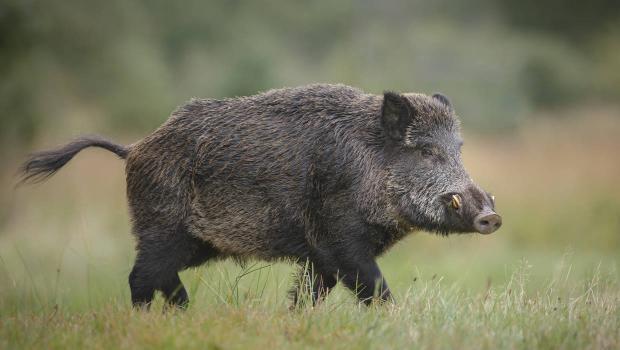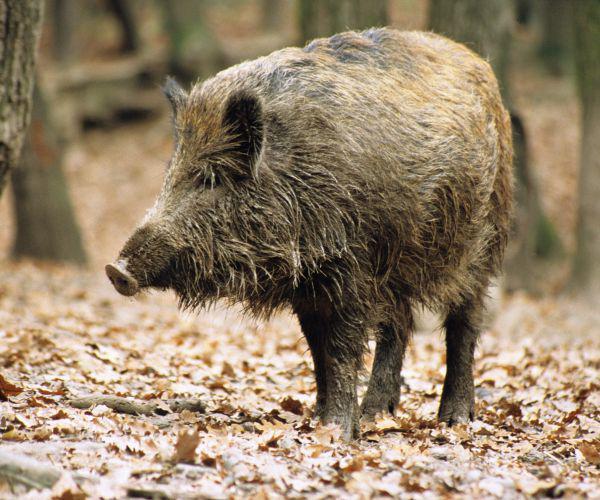The first image is the image on the left, the second image is the image on the right. Considering the images on both sides, is "There are at least two baby boars in the image on the right" valid? Answer yes or no. No. The first image is the image on the left, the second image is the image on the right. Analyze the images presented: Is the assertion "Right image shows young and adult hogs." valid? Answer yes or no. No. 